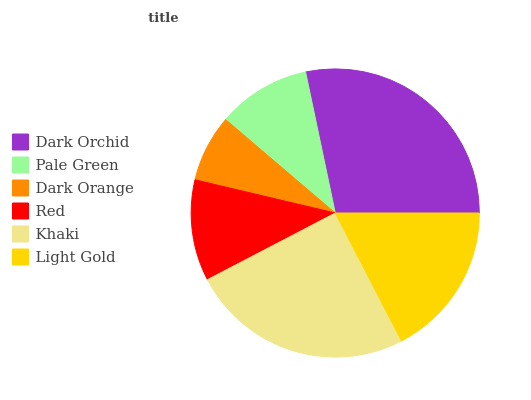Is Dark Orange the minimum?
Answer yes or no. Yes. Is Dark Orchid the maximum?
Answer yes or no. Yes. Is Pale Green the minimum?
Answer yes or no. No. Is Pale Green the maximum?
Answer yes or no. No. Is Dark Orchid greater than Pale Green?
Answer yes or no. Yes. Is Pale Green less than Dark Orchid?
Answer yes or no. Yes. Is Pale Green greater than Dark Orchid?
Answer yes or no. No. Is Dark Orchid less than Pale Green?
Answer yes or no. No. Is Light Gold the high median?
Answer yes or no. Yes. Is Red the low median?
Answer yes or no. Yes. Is Dark Orchid the high median?
Answer yes or no. No. Is Light Gold the low median?
Answer yes or no. No. 